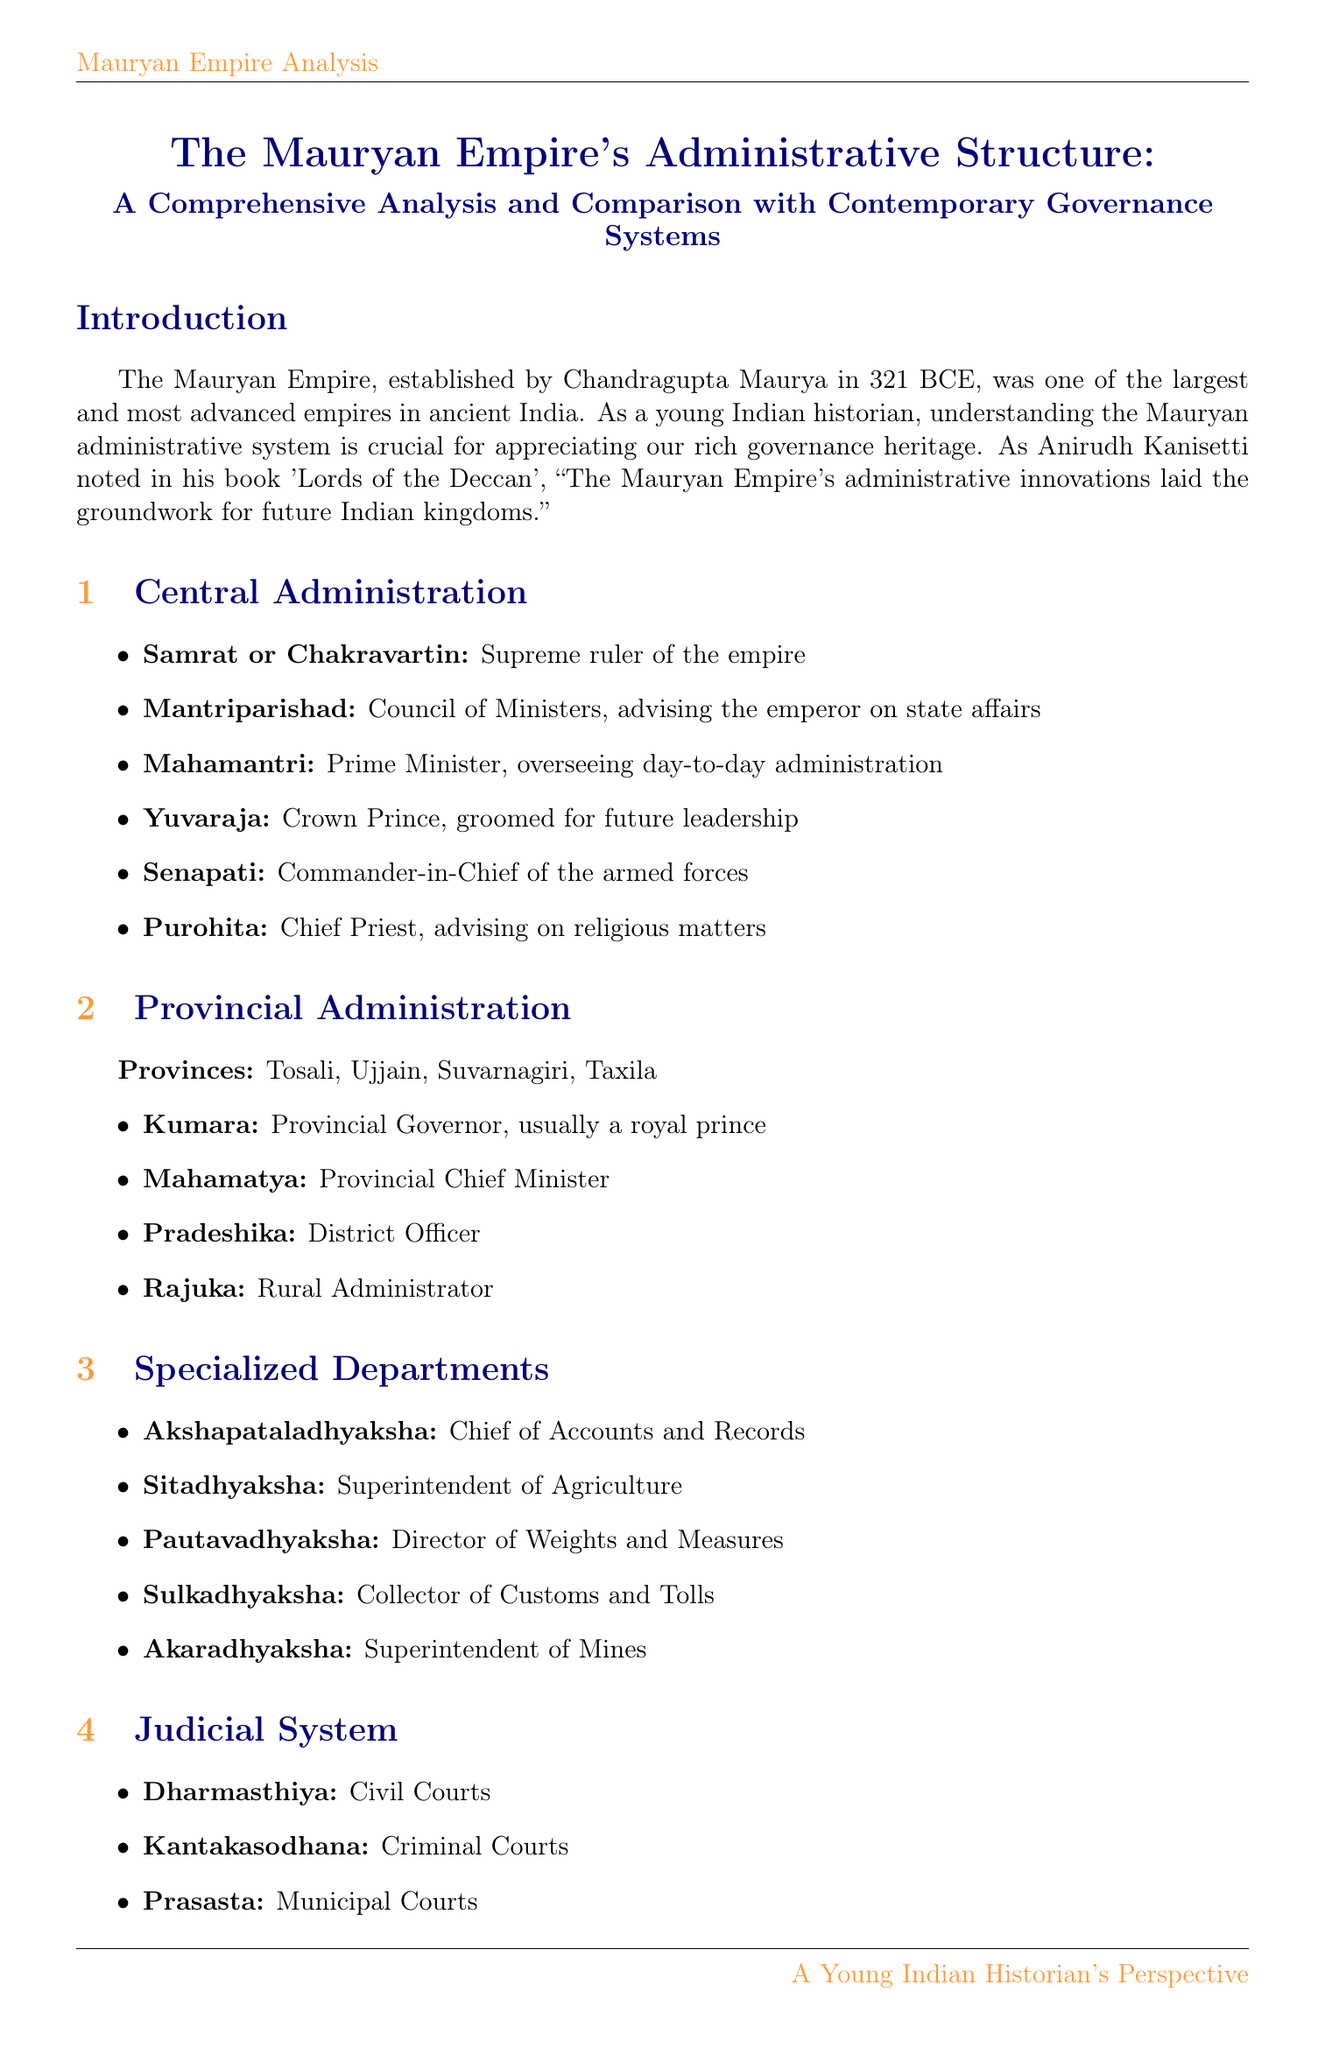What is the title of the report? The title of the report is provided in the "reportTitle" section of the document.
Answer: The Mauryan Empire's Administrative Structure: A Comprehensive Analysis and Comparison with Contemporary Governance Systems Who was the supreme ruler of the Mauryan Empire? The supreme ruler is referred to in the "centralAdministration" section of the document.
Answer: Samrat or Chakravartin What department is responsible for agriculture? The responsible department is listed among the specialized departments in the document.
Answer: Superintendent of Agriculture What influences the governance approach of the Achaemenid Empire? The factors influencing the governance approach are detailed in the "comparisonWithContemporaryEmpires" section of the document.
Answer: Zoroastrian influence What is the typical land revenue percentage in the Mauryan Empire? The percentage is mentioned under the revenue system section of the document.
Answer: 1/6th Which ruler is associated with the promotion of ethical governance principles? The ruler promoting ethical governance principles is noted in the "uniqueFeatures" section of the document.
Answer: Emperor Ashoka How did the Mauryan administrative system influence modern India? This influence is captured in the "legacyAndInfluence" section of the document.
Answer: Federal structure and civil service system In what year was the Mauryan Empire established? The year of establishment is mentioned in the introduction section of the document.
Answer: 321 BCE 